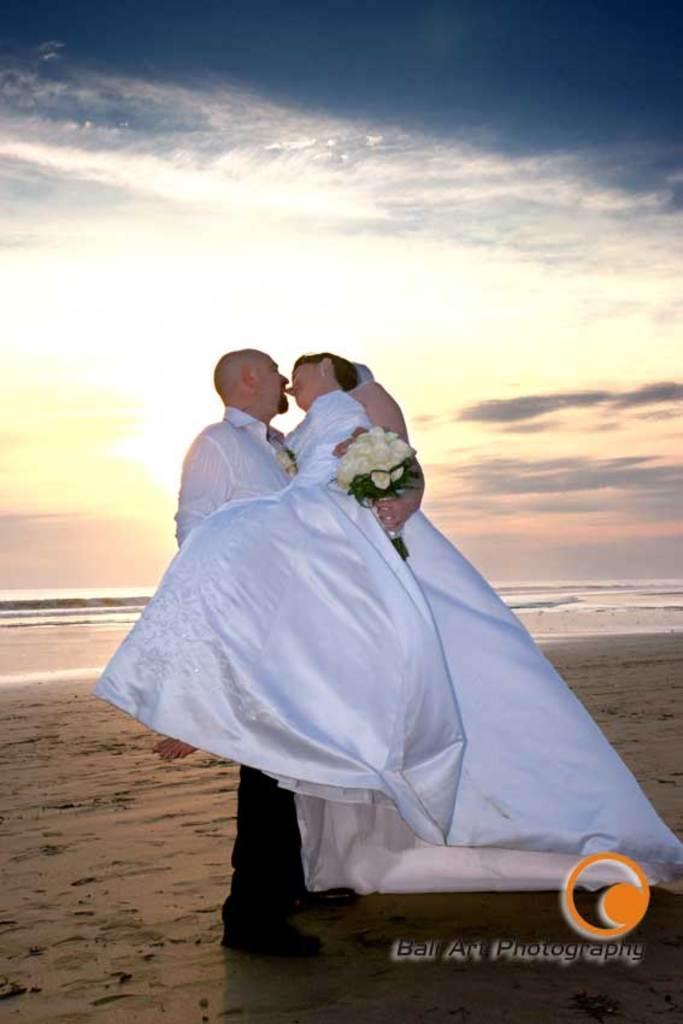Describe this image in one or two sentences. In this image there is a person standing and holding another person , and at the background there is water, sky and a watermark on the image. 